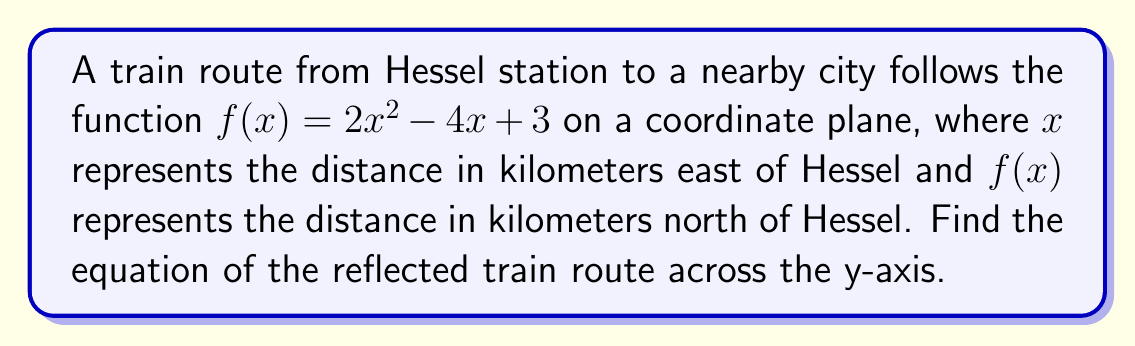Give your solution to this math problem. To reflect a function across the y-axis, we replace every $x$ with $-x$ in the original function. Let's go through this step-by-step:

1. The original function is $f(x) = 2x^2 - 4x + 3$

2. Replace every $x$ with $-x$:
   $f(-x) = 2(-x)^2 - 4(-x) + 3$

3. Simplify:
   $f(-x) = 2x^2 + 4x + 3$

   Note that $(-x)^2 = x^2$ because the square of a negative is positive.
   Also, $-4(-x) = 4x$ because the negative signs cancel out.

4. The resulting function $f(-x) = 2x^2 + 4x + 3$ is the reflection of the original function across the y-axis.

This new equation represents the reflected train route, where $x$ now represents the distance in kilometers west of Hessel, and $f(-x)$ still represents the distance in kilometers north of Hessel.
Answer: $f(-x) = 2x^2 + 4x + 3$ 